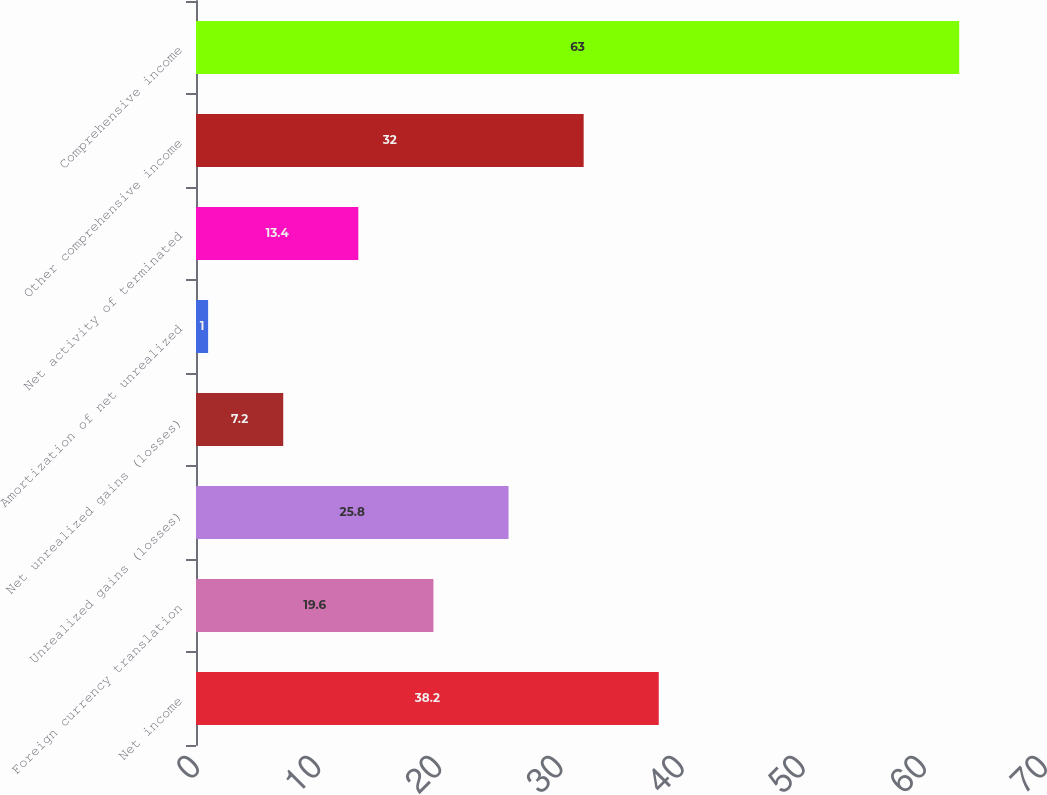Convert chart to OTSL. <chart><loc_0><loc_0><loc_500><loc_500><bar_chart><fcel>Net income<fcel>Foreign currency translation<fcel>Unrealized gains (losses)<fcel>Net unrealized gains (losses)<fcel>Amortization of net unrealized<fcel>Net activity of terminated<fcel>Other comprehensive income<fcel>Comprehensive income<nl><fcel>38.2<fcel>19.6<fcel>25.8<fcel>7.2<fcel>1<fcel>13.4<fcel>32<fcel>63<nl></chart> 